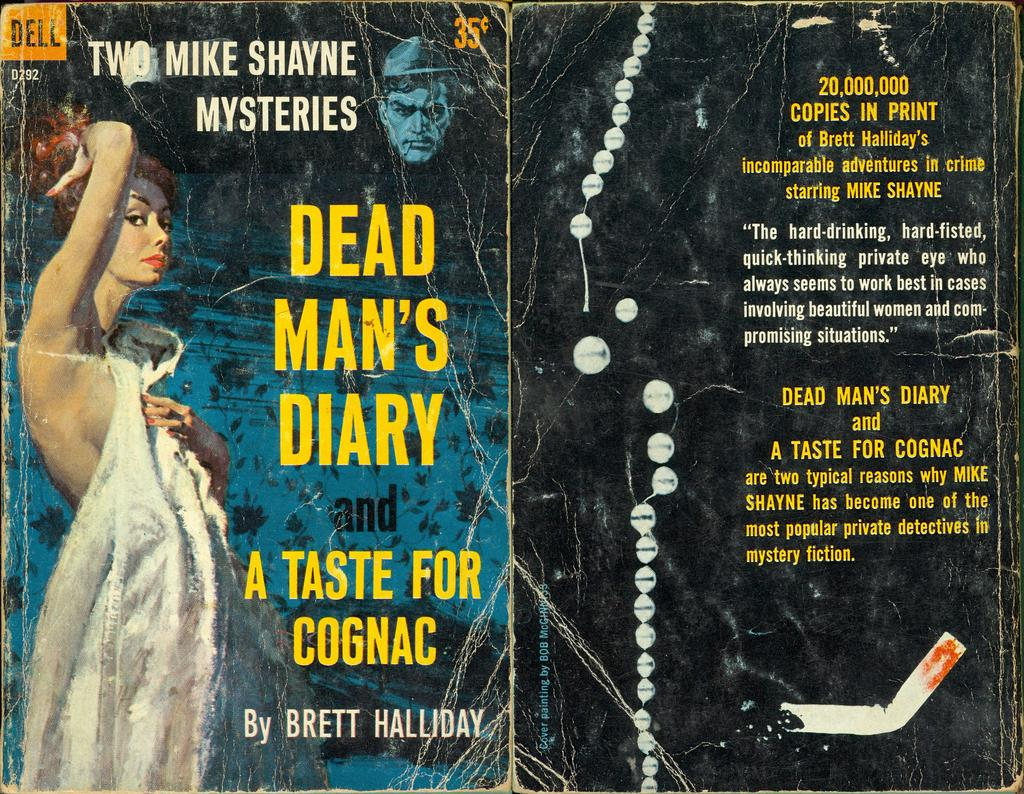<image>
Present a compact description of the photo's key features. A book cover by somebody named Brett Halliday. 